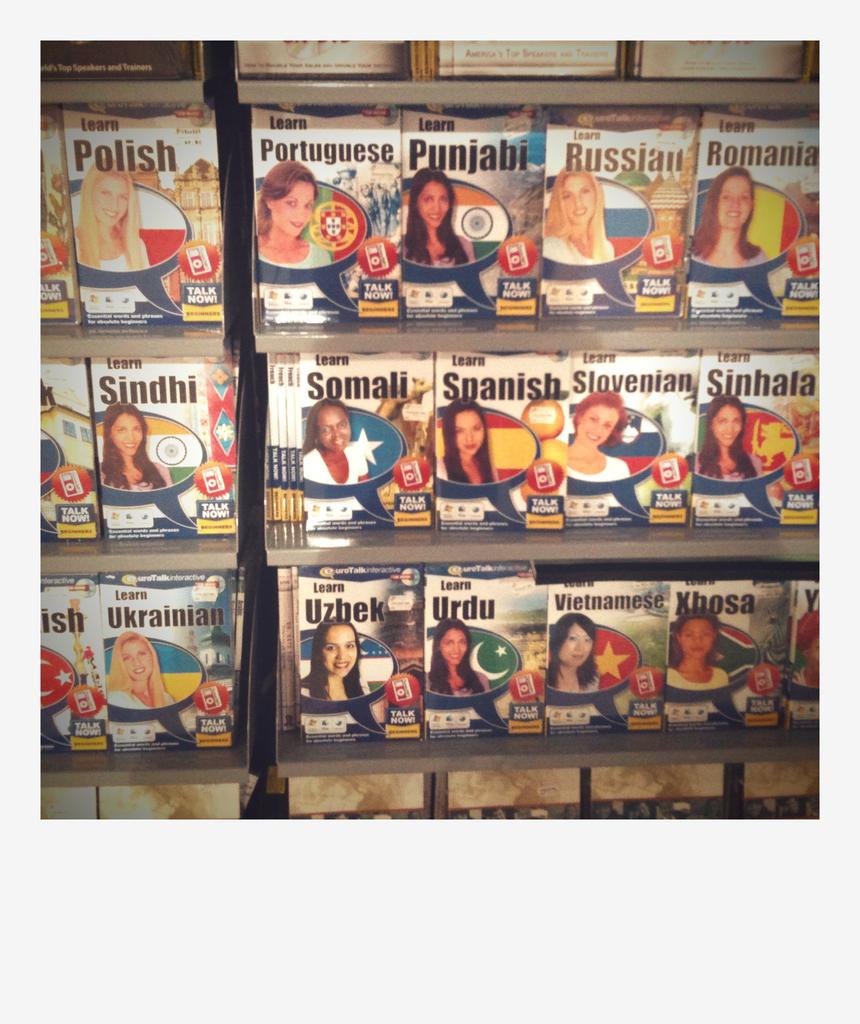How many countries are represented here?
Keep it short and to the point. 15. What language is posted on the front of the book near the top left?
Offer a very short reply. Polish. 